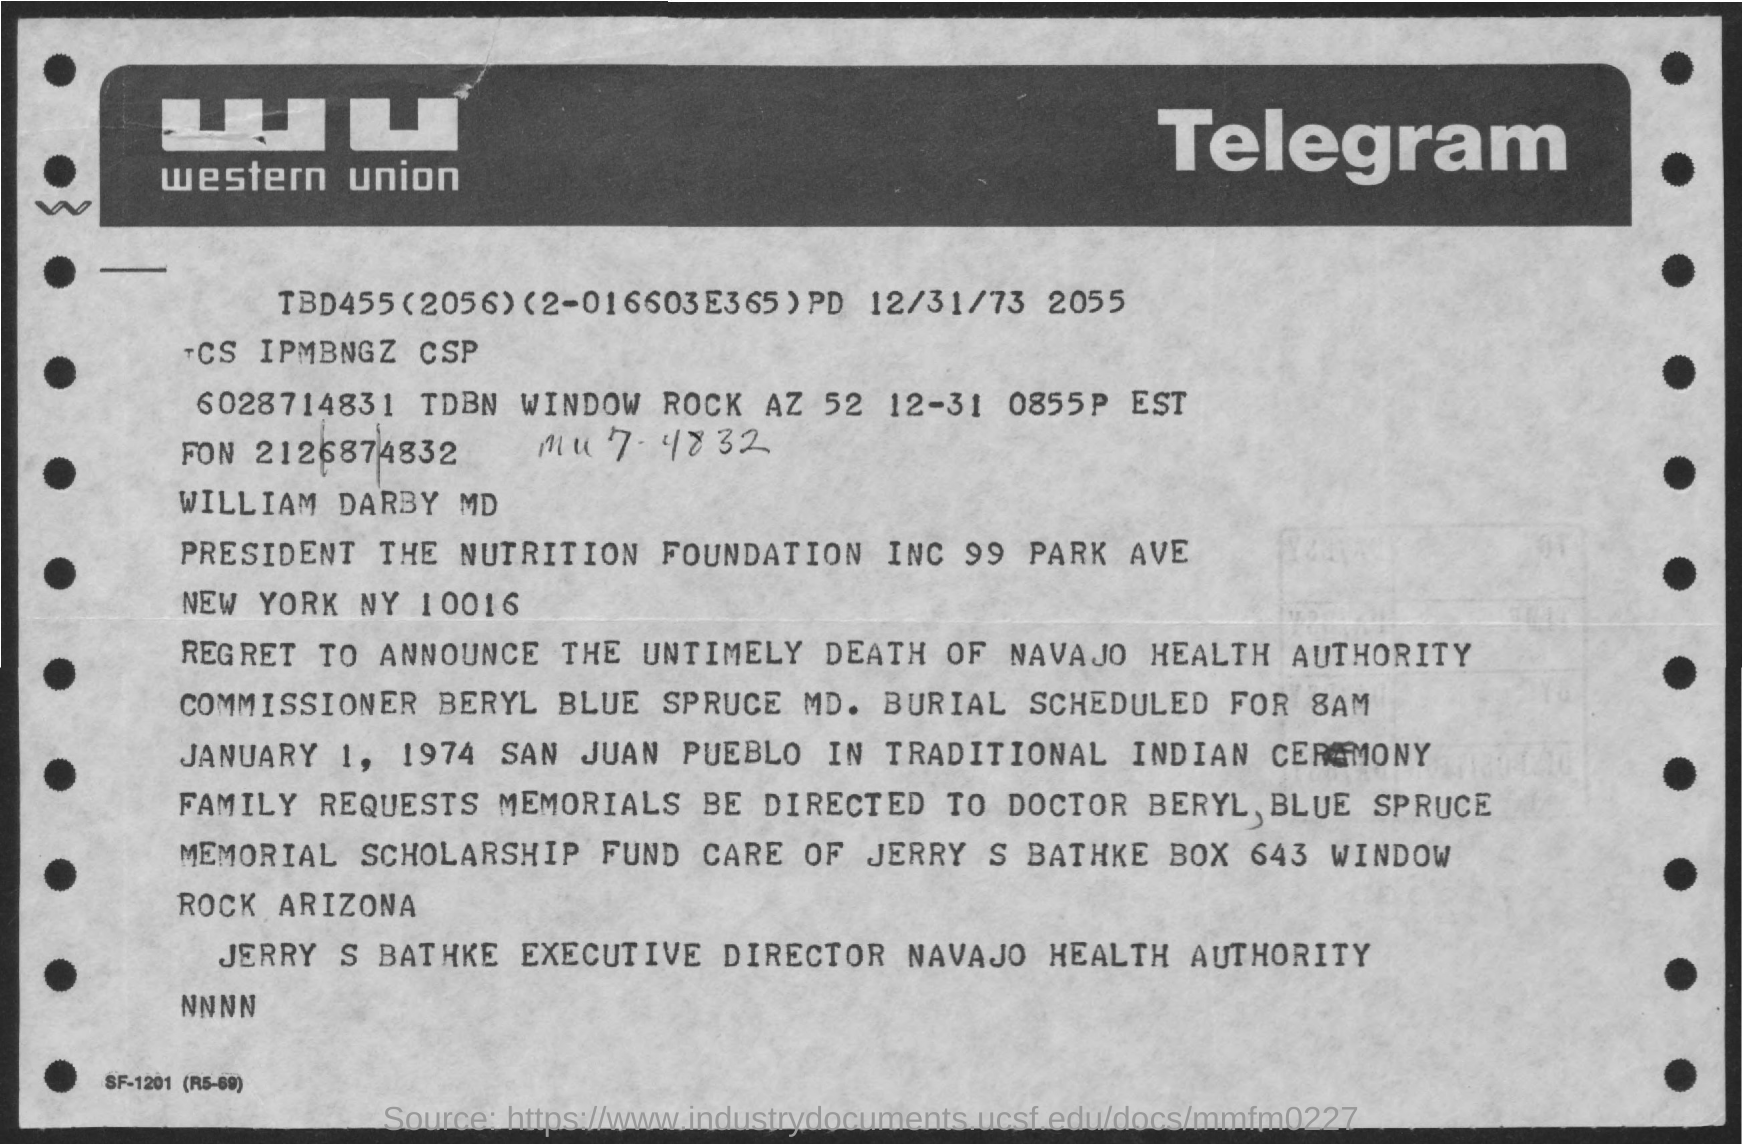What is the full form of WU?
Provide a short and direct response. Western union. Who is the Executive Director of Navajo Health Authority?
Provide a succinct answer. Jerry s bathke. 